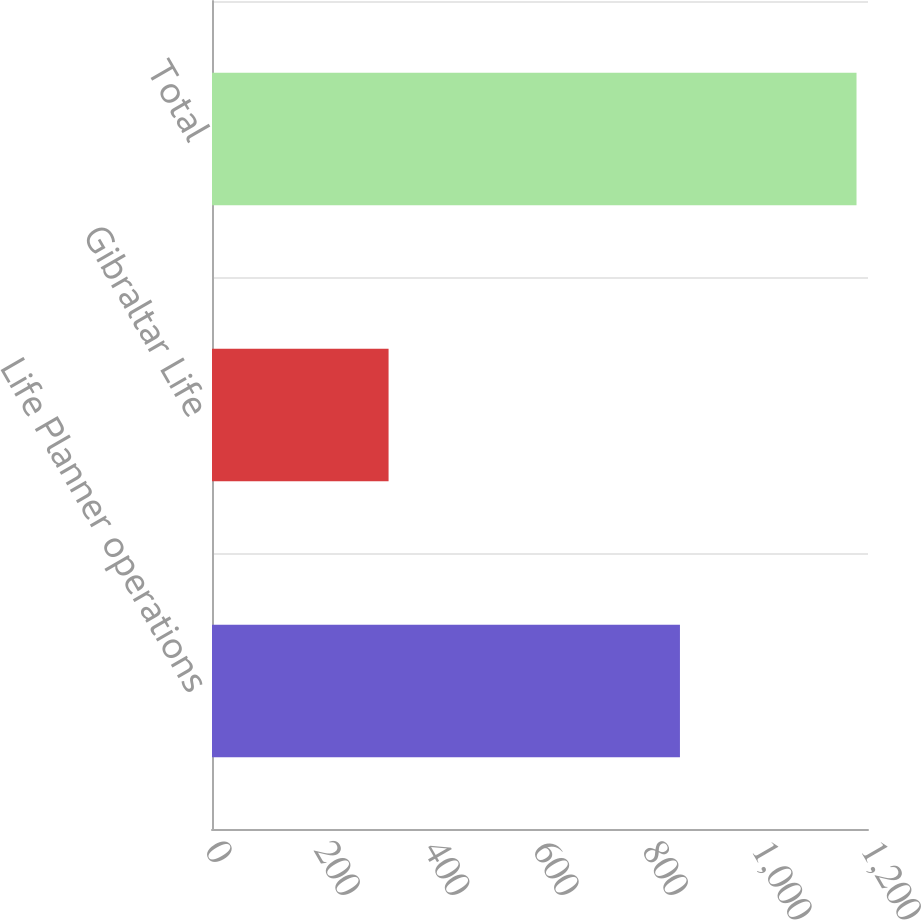Convert chart. <chart><loc_0><loc_0><loc_500><loc_500><bar_chart><fcel>Life Planner operations<fcel>Gibraltar Life<fcel>Total<nl><fcel>856<fcel>323<fcel>1179<nl></chart> 